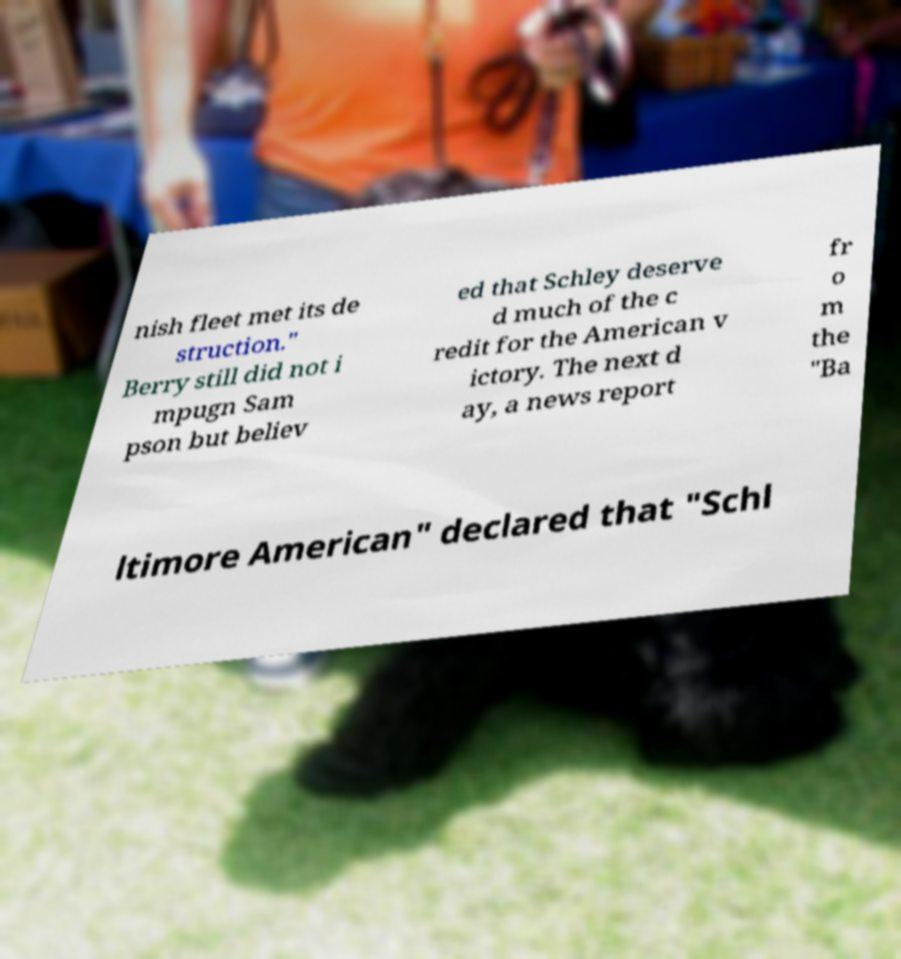What messages or text are displayed in this image? I need them in a readable, typed format. nish fleet met its de struction." Berry still did not i mpugn Sam pson but believ ed that Schley deserve d much of the c redit for the American v ictory. The next d ay, a news report fr o m the "Ba ltimore American" declared that "Schl 